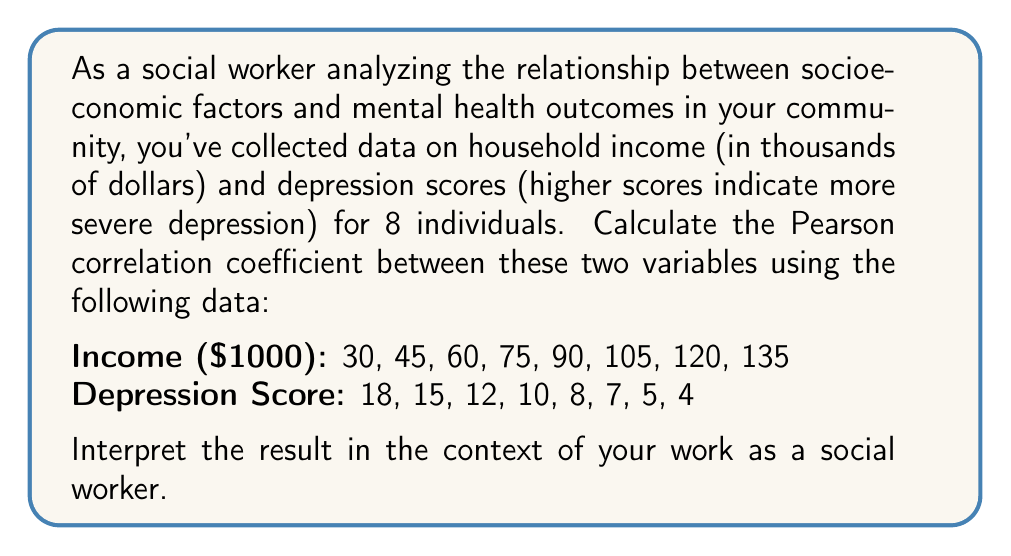Teach me how to tackle this problem. To calculate the Pearson correlation coefficient, we'll use the formula:

$$ r = \frac{\sum_{i=1}^{n} (x_i - \bar{x})(y_i - \bar{y})}{\sqrt{\sum_{i=1}^{n} (x_i - \bar{x})^2} \sqrt{\sum_{i=1}^{n} (y_i - \bar{y})^2}} $$

Where:
$x_i$ = income values
$y_i$ = depression scores
$\bar{x}$ = mean of income values
$\bar{y}$ = mean of depression scores
$n$ = number of data points (8 in this case)

Step 1: Calculate means
$\bar{x} = (30 + 45 + 60 + 75 + 90 + 105 + 120 + 135) / 8 = 82.5$
$\bar{y} = (18 + 15 + 12 + 10 + 8 + 7 + 5 + 4) / 8 = 9.875$

Step 2: Calculate $(x_i - \bar{x})$, $(y_i - \bar{y})$, $(x_i - \bar{x})^2$, $(y_i - \bar{y})^2$, and $(x_i - \bar{x})(y_i - \bar{y})$ for each data point.

Step 3: Sum up the values calculated in Step 2:
$\sum (x_i - \bar{x})(y_i - \bar{y}) = -3712.5$
$\sum (x_i - \bar{x})^2 = 24375$
$\sum (y_i - \bar{y})^2 = 165.875$

Step 4: Apply the formula:

$$ r = \frac{-3712.5}{\sqrt{24375} \sqrt{165.875}} = -0.9728 $$

The Pearson correlation coefficient is approximately -0.9728.

Interpretation: This strong negative correlation (-0.9728) indicates that as household income increases, depression scores tend to decrease significantly. In the context of social work, this suggests a robust inverse relationship between socioeconomic status (represented by income) and mental health outcomes (represented by depression scores). This information can be valuable for developing targeted interventions and advocating for policies that address the mental health needs of lower-income individuals in the community.
Answer: The Pearson correlation coefficient is approximately -0.9728, indicating a strong negative correlation between household income and depression scores. 